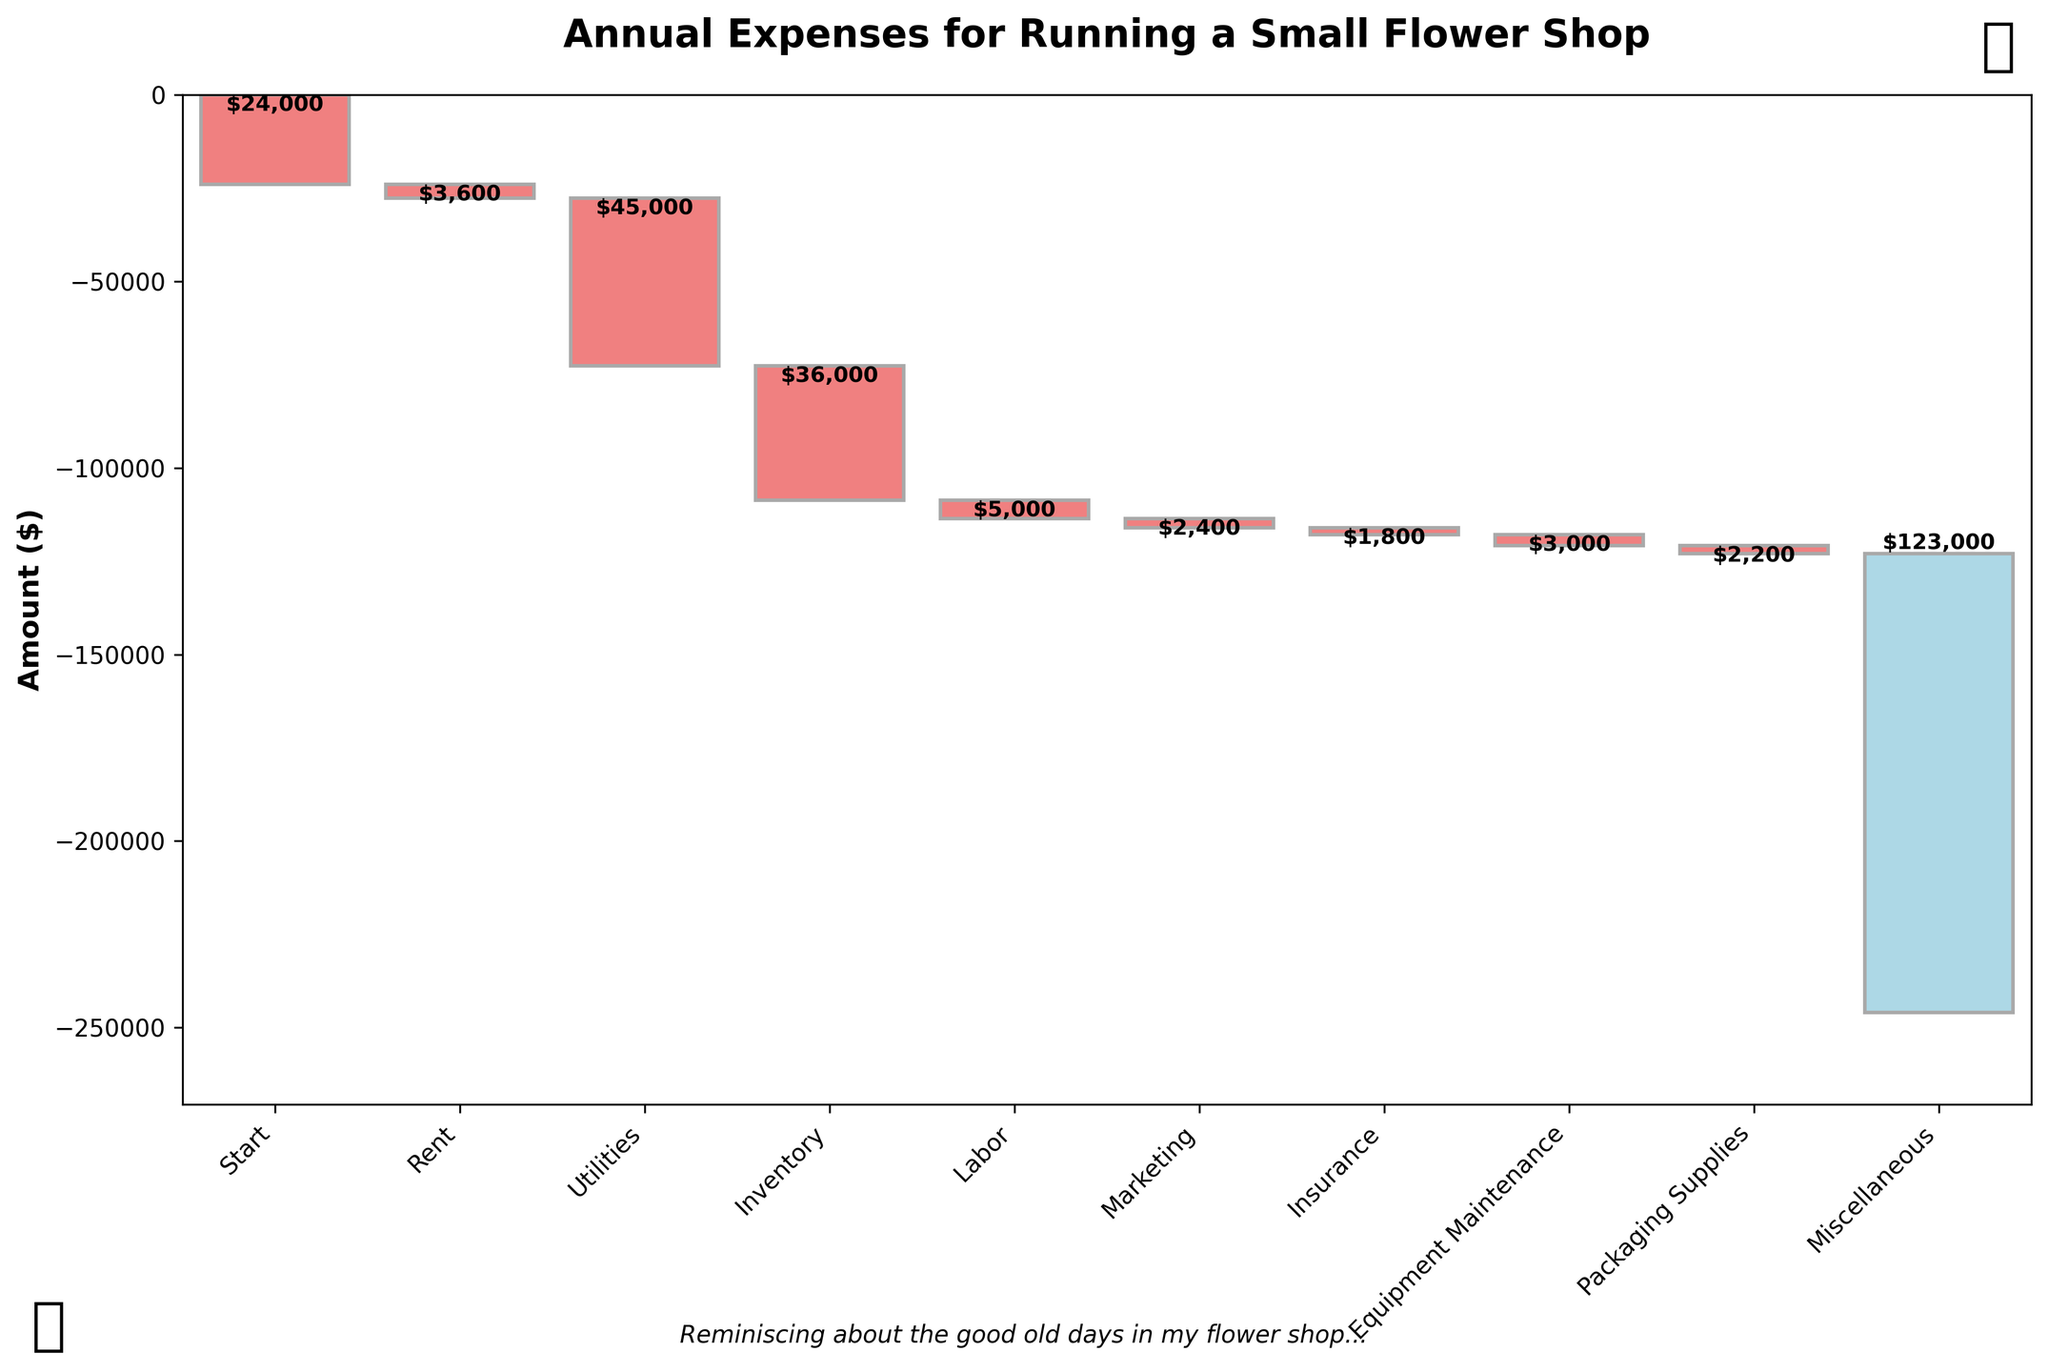What is the title of the chart? The title of the chart is located at the top and provides an overview of what the chart is about.
Answer: Annual Expenses for Running a Small Flower Shop How many categories of expenses are shown in the chart? The categories of expenses are listed along the horizontal axis of the chart, including the start and total expenses as additional points. Count these categories.
Answer: 9 Which expense category has the highest cost? Identify the bar that extends the most downwards from its starting point, indicating the largest negative value.
Answer: Inventory How much is spent on labor annually? Find the bar labeled "Labor" and refer to the value label on or next to it.
Answer: -36000 What is the final total expense amount for the year? Look at the last bar on the chart labeled "Total Expenses" and check its value.
Answer: -123000 What is the combined cost of rent, utilities, and insurance? Sum the values of the bars labeled "Rent," "Utilities," and "Insurance." Calculate: -24000 + (-3600) + (-2400).
Answer: -30000 How do the costs for marketing and packaging supplies compare? Compare the lengths of the bars for "Marketing" and "Packaging Supplies," or their numerical values if shown.
Answer: Marketing is higher than Packaging Supplies Which expense category has the least cost? Identify the bar with the smallest absolute value, indicating the smallest expense.
Answer: Equipment Maintenance What percentage of the total expenses does the rent constitute? Calculate the percentage by dividing the rent cost by the total expenses and then multiplying by 100. Use values: (-24000 / -123000) * 100.
Answer: Approximately 19.5% If the price for marketing were reduced by half, what would be the new total annual expenses? Calculate the new marketing cost, which is half the original. Then, sum up the rest of the expenses with this new value and add from the existing start value. Calculate: -123000 + (5000 / 2).
Answer: -120500 